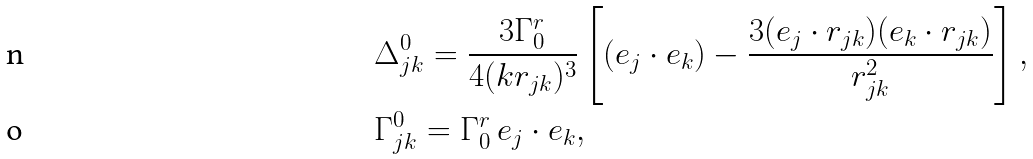Convert formula to latex. <formula><loc_0><loc_0><loc_500><loc_500>& \Delta _ { j k } ^ { 0 } = \frac { 3 \Gamma _ { 0 } ^ { r } } { 4 ( k r _ { j k } ) ^ { 3 } } \left [ ( { e } _ { j } \cdot { e } _ { k } ) - \frac { 3 ( { e } _ { j } \cdot { r } _ { j k } ) ( { e } _ { k } \cdot { r } _ { j k } ) } { r _ { j k } ^ { 2 } } \right ] , \\ & \Gamma _ { j k } ^ { 0 } = \Gamma _ { 0 } ^ { r } \, { e } _ { j } \cdot { e } _ { k } ,</formula> 